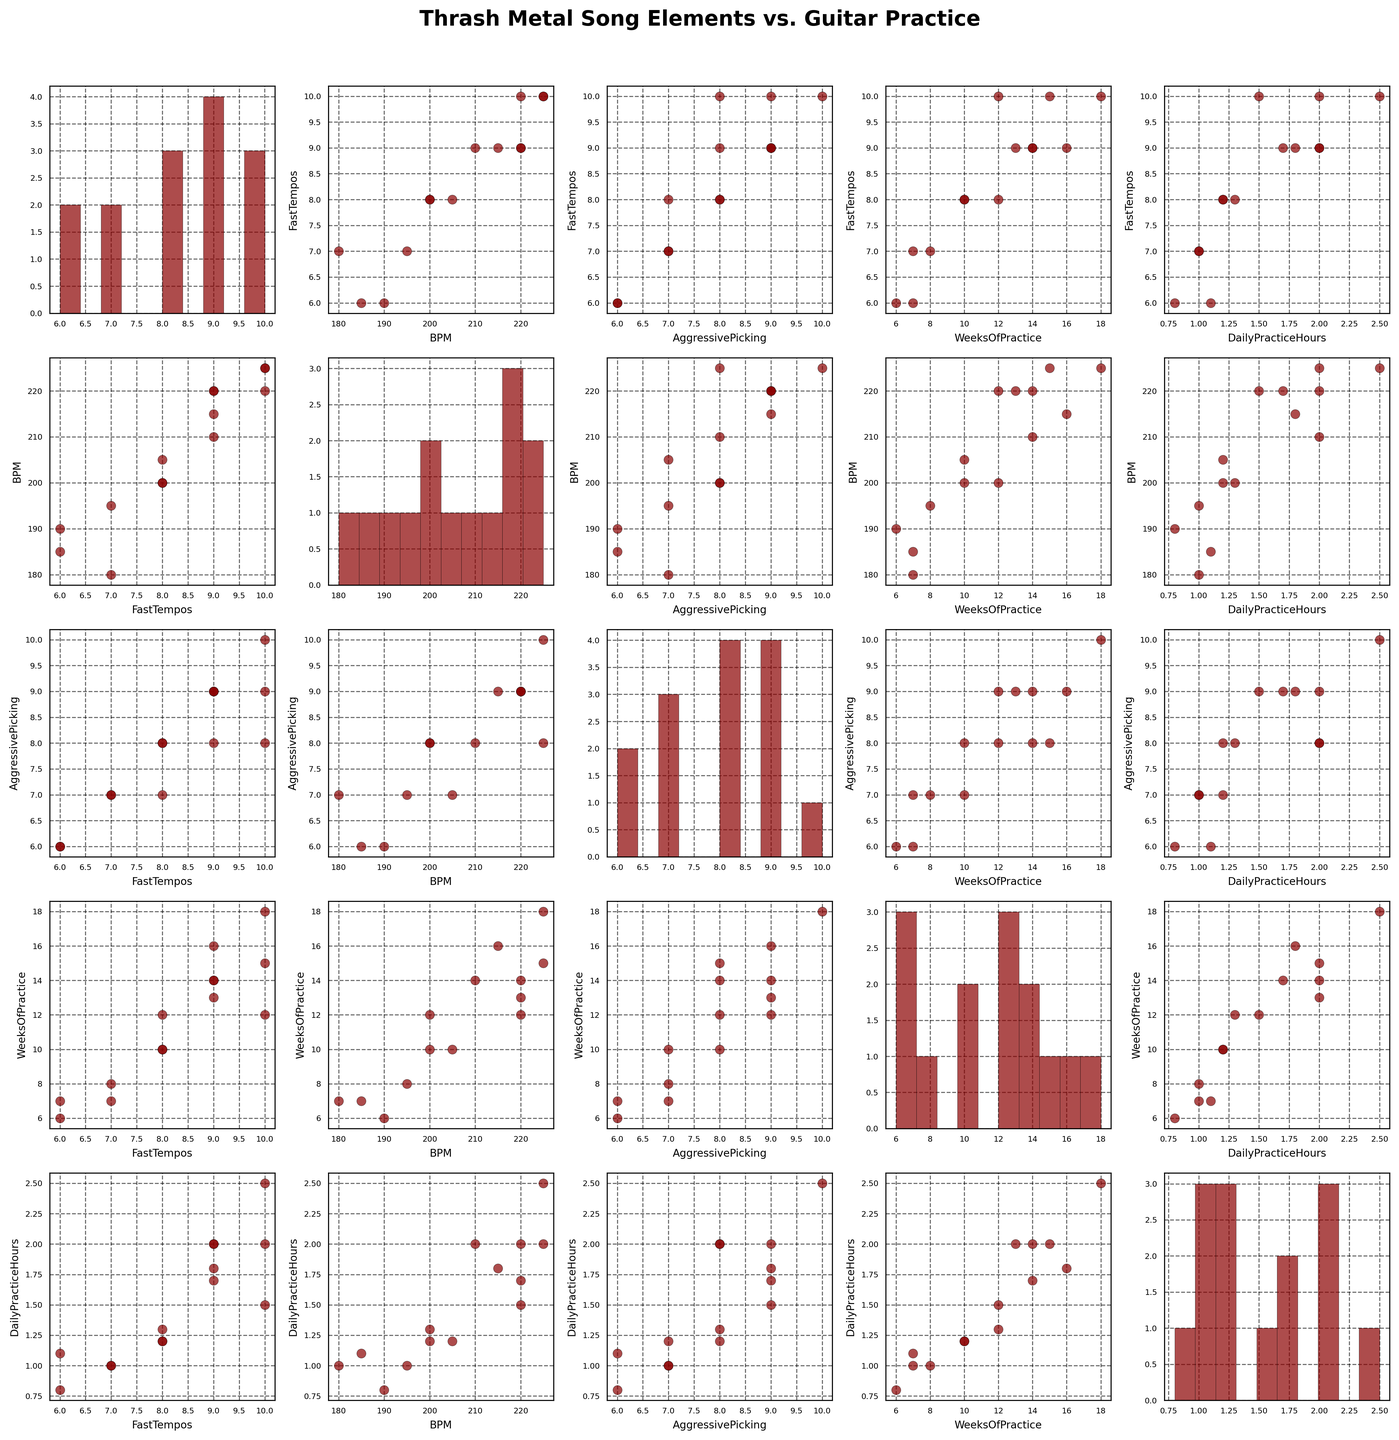What visual elements are used in the scatter plot matrix? The scatter plot matrix uses scatter plots to represent relationships between different pairs of variables, with a histogram on the diagonal to show the distribution of each variable. It includes data points in red color with black edges and grids, labels for axes, and grids.
Answer: Scatter plots, histograms, red points, black edges, grids, axis labels What relationships can you observe between "WeeksOfPractice" and "DailyPracticeHours"? By looking at the scatter plot between "WeeksOfPractice" and "DailyPracticeHours", you may notice that as the weeks of practice increase, the daily practice hours tend to increase as well. This indicates a positive correlation.
Answer: Positive correlation Which song has the highest "BPM" and how does it compare with its "WeeksOfPractice"? The song "Angel of Death" has the highest BPM of 225. Comparing this with its "WeeksOfPractice", the value is 18 weeks.
Answer: "Angel of Death", BPM 225, WeeksOfPractice 18 What's a common factor among songs that have a "FastTempos" value of 10? Songs with a "FastTempos" value of 10, such as "Master of Puppets," "Angel of Death," and "Blackened," tend to also have high BPM values above 220 and "AggressivePicking" values around 9 or 10.
Answer: High BPM, High AggressivePicking Is there any visible correlation between "AggressivePicking" and "DailyPracticeHours"? The scatter plot between "AggressivePicking" and "DailyPracticeHours" shows that higher aggressive picking values are generally associated with more daily practice hours, indicating a slight positive correlation.
Answer: Slight positive correlation Which two songs have the closest "BPM" values, and what are those BPM values? "Whiplash" and "War Ensemble" both have a BPM value of 220, which is the closest match among the songs.
Answer: "Whiplash" and "War Ensemble," BPM 220 How many songs have a "DailyPracticeHours" value greater than 2 hours? Looking at the histogram and data points in the scatter plot related to "DailyPracticeHours," there are three songs: "Raining Blood," "Angel of Death," and "War Ensemble" with practice hours greater than 2.
Answer: Three songs Which song shows the highest level of "AggressivePicking" and how does its "DailyPracticeHours" compare? "Angel of Death" shows the highest level of "AggressivePicking" at 10, with "DailyPracticeHours" at 2.5 hours, the highest among all songs.
Answer: "Angel of Death," Aggressive Picking 10, Daily Practice Hours 2.5 What insights can you draw from the histogram for "WeeksOfPractice"? The histogram for "WeeksOfPractice" shows that most values cluster below 20 weeks, with a noticeable peak between 10 and 16 weeks, suggesting that most guitarists practice within this range for these songs.
Answer: Values cluster below 20 weeks, peak between 10 and 16 weeks 